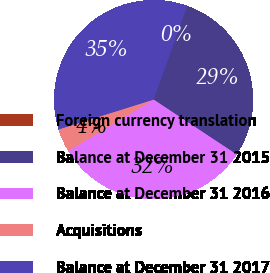<chart> <loc_0><loc_0><loc_500><loc_500><pie_chart><fcel>Foreign currency translation<fcel>Balance at December 31 2015<fcel>Balance at December 31 2016<fcel>Acquisitions<fcel>Balance at December 31 2017<nl><fcel>0.02%<fcel>28.79%<fcel>32.06%<fcel>3.8%<fcel>35.33%<nl></chart> 